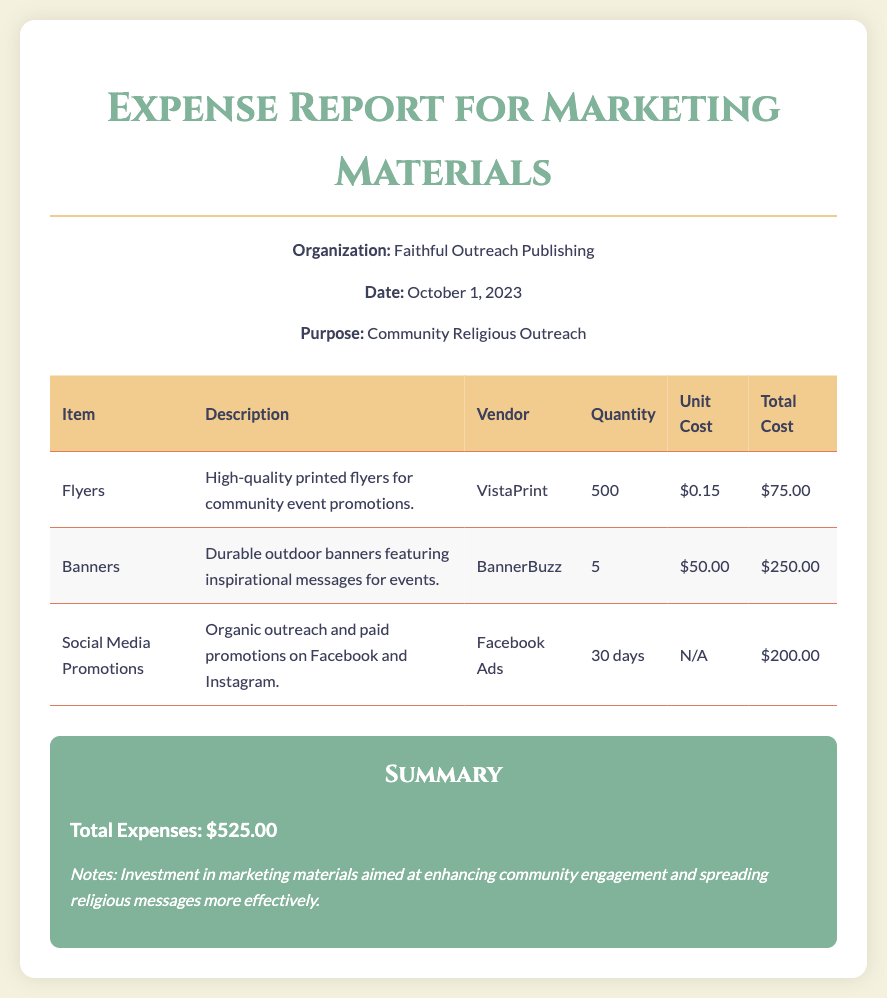What is the organization title? The organization title mentioned in the document is associated with the implementation of the outreach program, which is "Faithful Outreach Publishing."
Answer: Faithful Outreach Publishing When was the expense report created? The document specifies the date of the report to be integral for audit purposes, which is "October 1, 2023."
Answer: October 1, 2023 What is the total expenses amount? The total expenses are calculated by summing up the costs stated, resulting in the amount of "$525.00."
Answer: $525.00 How many flyers were purchased? The quantity of flyers listed is required for understanding the scale of marketing, which is "500."
Answer: 500 Who provided the social media promotions? The document attributes the social media promotional efforts to a specific vendor, which is identified as "Facebook Ads."
Answer: Facebook Ads What was the unit cost of a banner? The unit cost of the banners provides insight into the pricing strategy for marketing materials, which is "$50.00."
Answer: $50.00 What type of materials were detailed in the report? This question pertains to evaluating the various marketing items discussed, namely "Flyers, Banners, Social Media Promotions."
Answer: Flyers, Banners, Social Media Promotions What is the purpose stated for these expenses? Understanding the objective of the marketing expenditure is essential, which is for "Community Religious Outreach."
Answer: Community Religious Outreach 